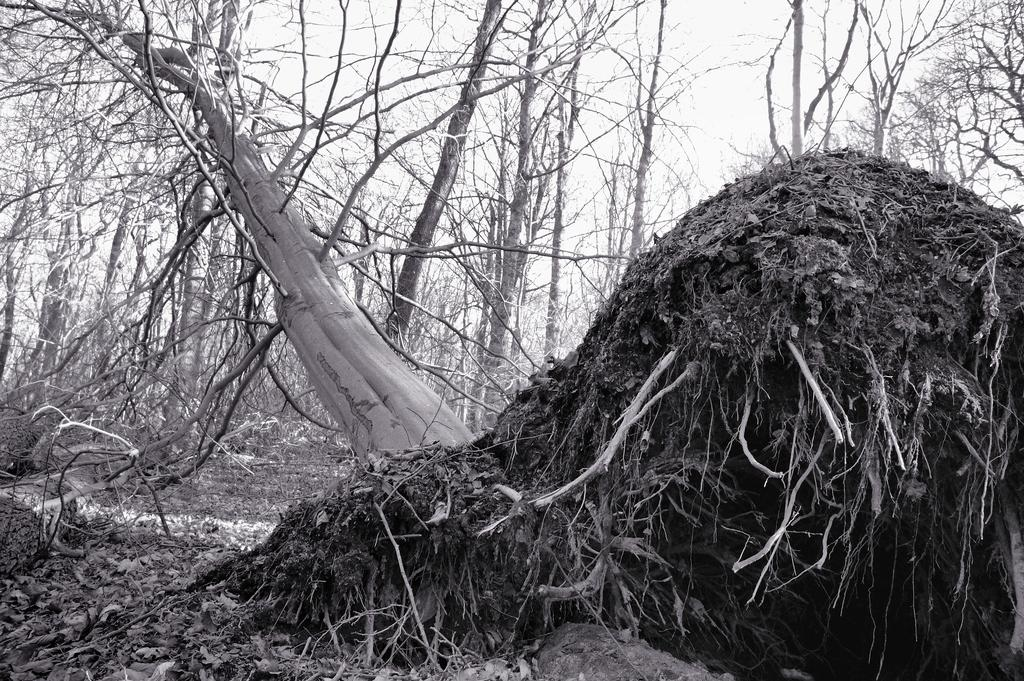What type of natural feature can be seen in the image? There are roots visible in the image. What else can be seen in the image besides the roots? There are many trees in the image. What is visible in the background of the image? The sky is visible in the background of the image. What is the color scheme of the image? The image is black and white. Where can the grape be found in the image? There are no grapes present in the image. What type of adhesive is used to attach the roots to the trees in the image? There is no glue or adhesive visible in the image; the roots and trees are naturally connected. 